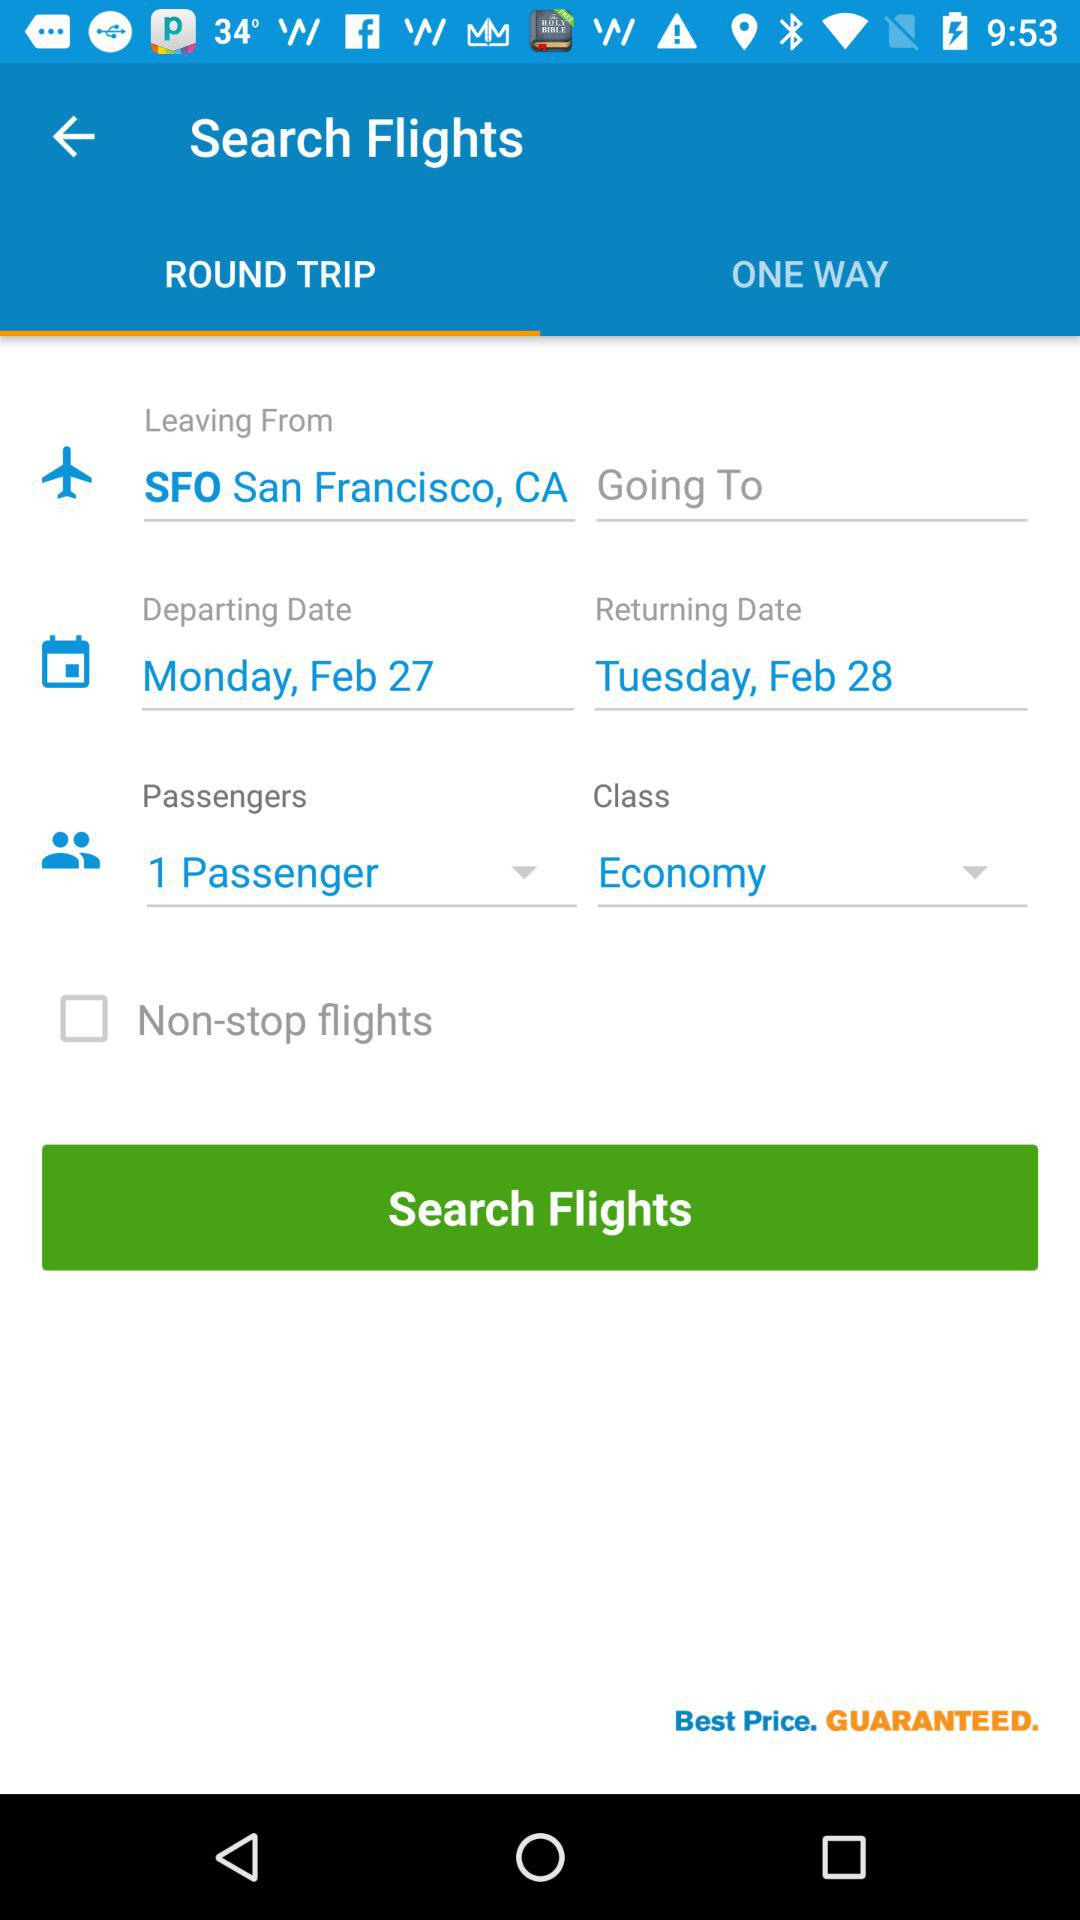What is the departing date? The departing date is Monday, February 27. 